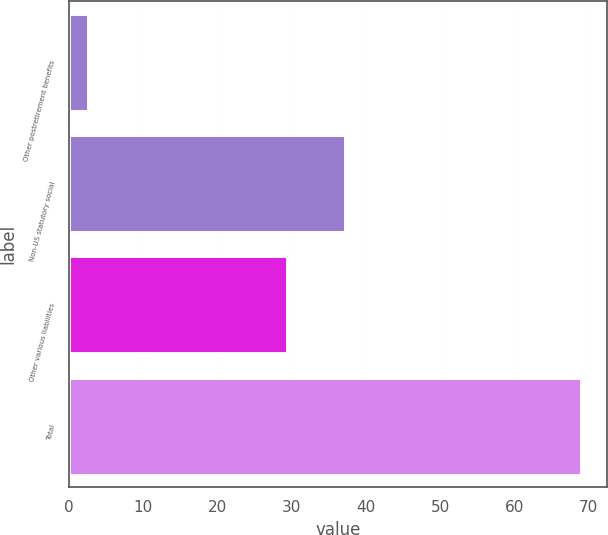Convert chart. <chart><loc_0><loc_0><loc_500><loc_500><bar_chart><fcel>Other postretirement benefits<fcel>Non-US statutory social<fcel>Other various liabilities<fcel>Total<nl><fcel>2.5<fcel>37.1<fcel>29.4<fcel>69<nl></chart> 